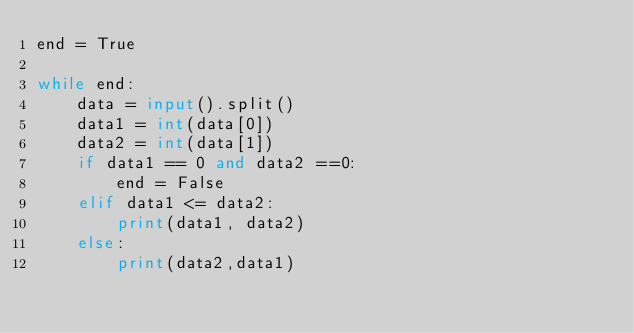Convert code to text. <code><loc_0><loc_0><loc_500><loc_500><_Python_>end = True

while end:
    data = input().split()
    data1 = int(data[0])
    data2 = int(data[1])
    if data1 == 0 and data2 ==0:
        end = False
    elif data1 <= data2:
        print(data1, data2)
    else:
        print(data2,data1)</code> 